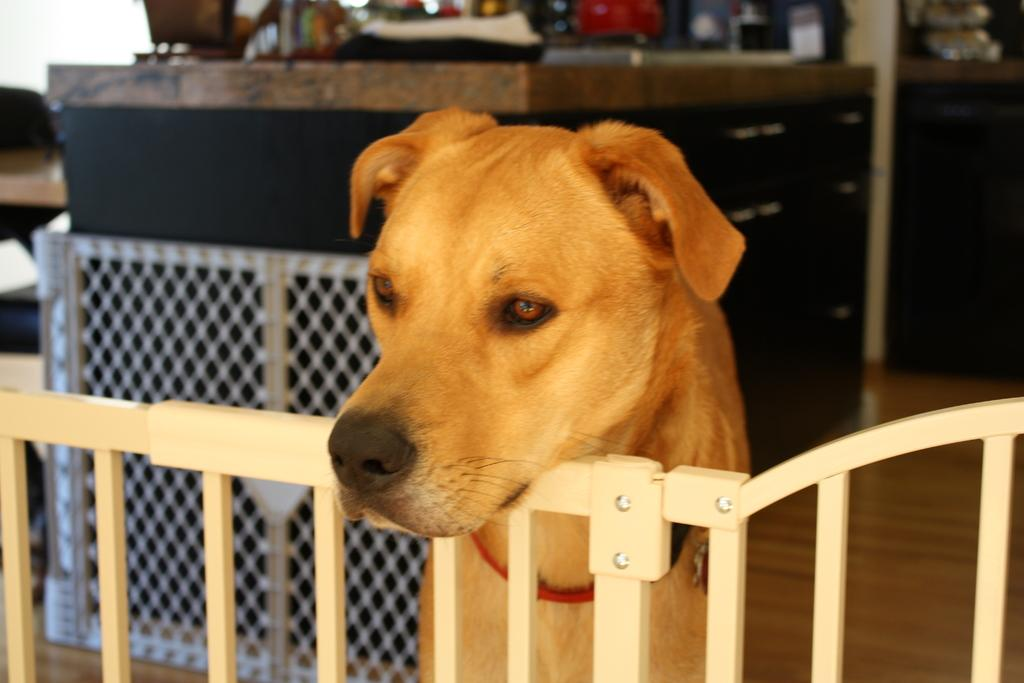What type of animal is in the image? There is a brown dog in the image. Where is the dog positioned in the image? The dog is standing in the front. What is the color of the grill in the image? The grill in the image is silver. What piece of furniture can be seen in the image? There is a table in the image. What architectural feature is visible at the bottom front of the image? There is a gate visible in the front bottom side of the image. What type of guitar is the dog playing in the image? There is no guitar present in the image; it features a brown dog standing in the front. How many cushions are on the table in the image? There is no cushion present on the table in the image. 